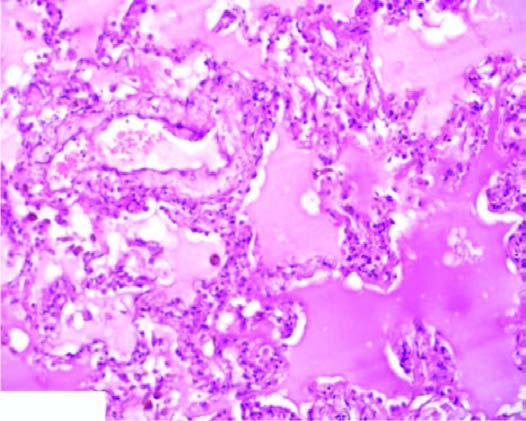do the nuclei of affected tubules contain eosinophilic, granular, homogeneous and pink proteinaceous oedema fluid along with some rbcs and inflammatory cells?
Answer the question using a single word or phrase. No 